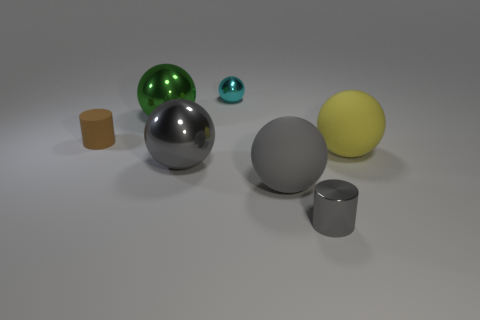Does the yellow rubber sphere have the same size as the green metallic object?
Your answer should be compact. Yes. The tiny thing left of the tiny metal thing that is behind the small brown cylinder is made of what material?
Make the answer very short. Rubber. How many cylinders are the same color as the small ball?
Provide a succinct answer. 0. Are there any other things that are made of the same material as the yellow ball?
Your answer should be very brief. Yes. Is the number of cyan things that are in front of the gray matte sphere less than the number of big gray things?
Your response must be concise. Yes. There is a ball that is right of the small cylinder that is in front of the yellow sphere; what color is it?
Ensure brevity in your answer.  Yellow. There is a yellow thing that is in front of the small cylinder left of the tiny thing that is behind the small matte cylinder; what is its size?
Provide a short and direct response. Large. Are there fewer small brown cylinders that are to the left of the gray metal cylinder than large metallic objects that are to the left of the small brown rubber cylinder?
Ensure brevity in your answer.  No. What number of big yellow things are the same material as the yellow ball?
Keep it short and to the point. 0. Is there a yellow ball that is to the left of the big gray sphere to the right of the small shiny thing that is behind the tiny rubber cylinder?
Offer a terse response. No. 